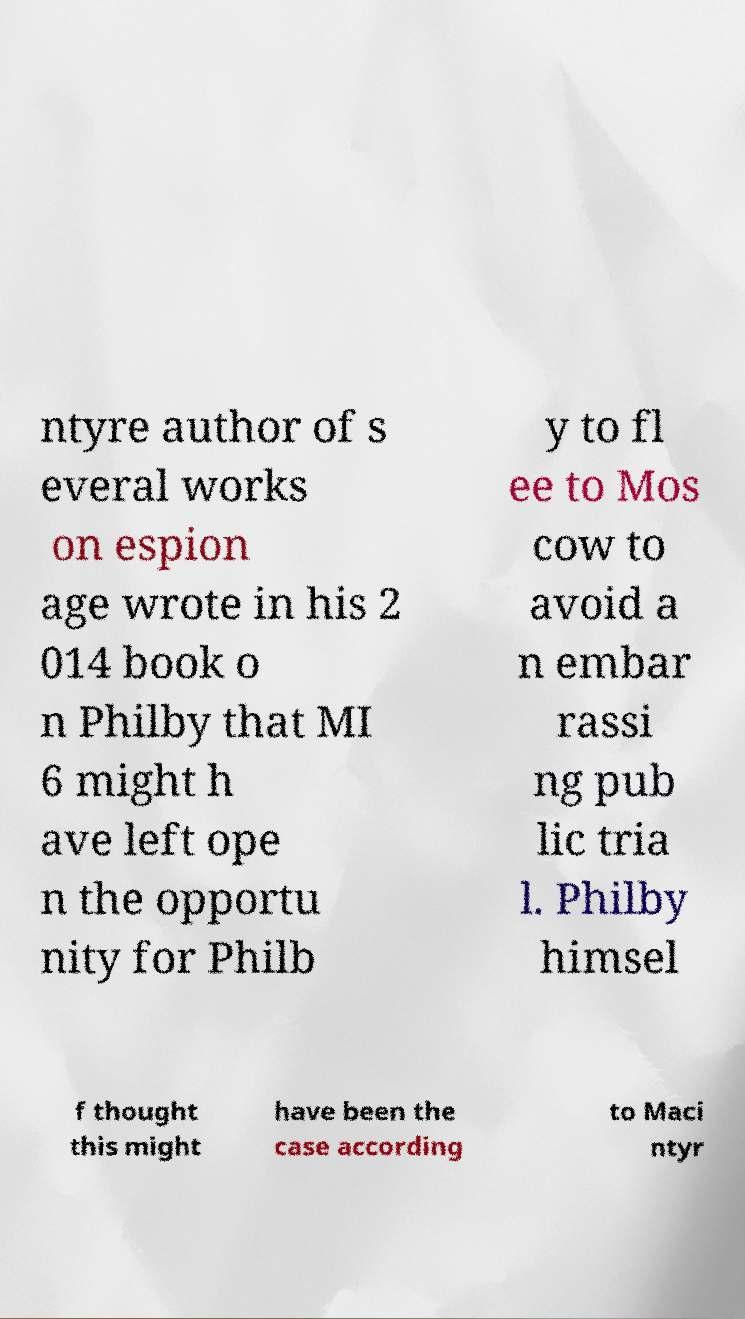Can you read and provide the text displayed in the image?This photo seems to have some interesting text. Can you extract and type it out for me? ntyre author of s everal works on espion age wrote in his 2 014 book o n Philby that MI 6 might h ave left ope n the opportu nity for Philb y to fl ee to Mos cow to avoid a n embar rassi ng pub lic tria l. Philby himsel f thought this might have been the case according to Maci ntyr 